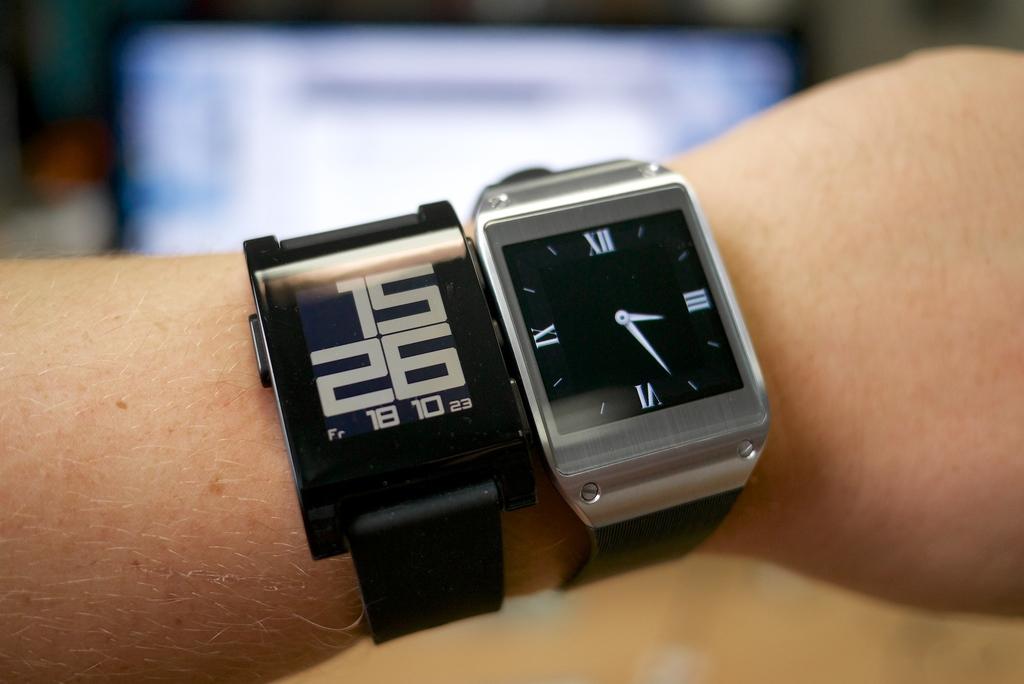What is the time on the watches in this picture?
Your answer should be very brief. 15:26. What are all the numbers on the left?
Give a very brief answer. 15 26 18 10 23. 